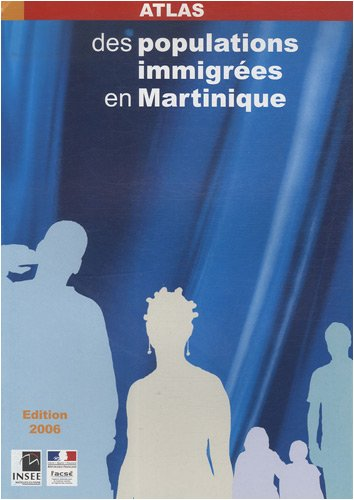How can this book be utilized by policymakers or researchers? Researchers and policymakers can use the statistical data and maps in the atlas to inform decisions on urban planning, resource allocation, and social services tailored to meet the needs of diverse communities in Martinique. 